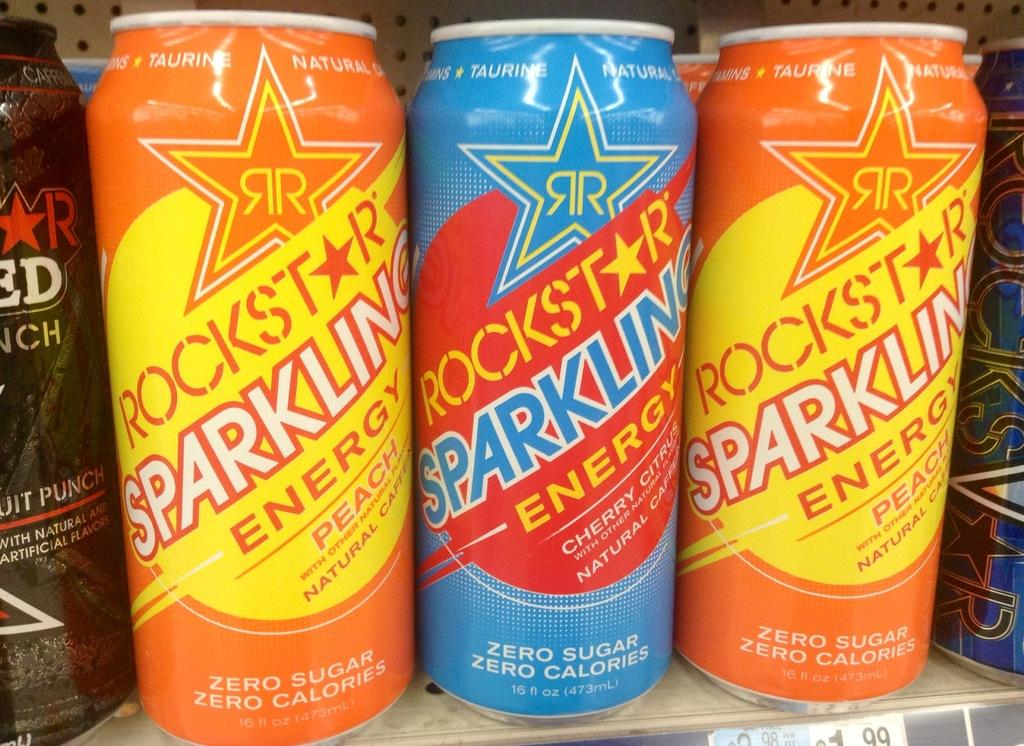<image>
Render a clear and concise summary of the photo. Three cans of Rockstar brand sparkling energy drink. 